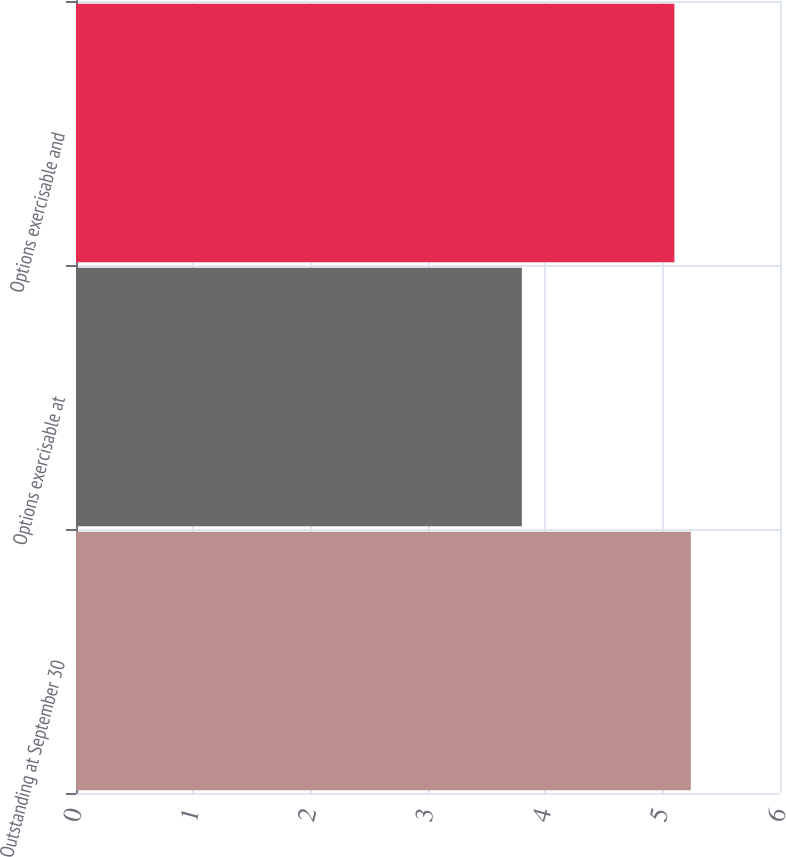Convert chart. <chart><loc_0><loc_0><loc_500><loc_500><bar_chart><fcel>Outstanding at September 30<fcel>Options exercisable at<fcel>Options exercisable and<nl><fcel>5.24<fcel>3.8<fcel>5.1<nl></chart> 